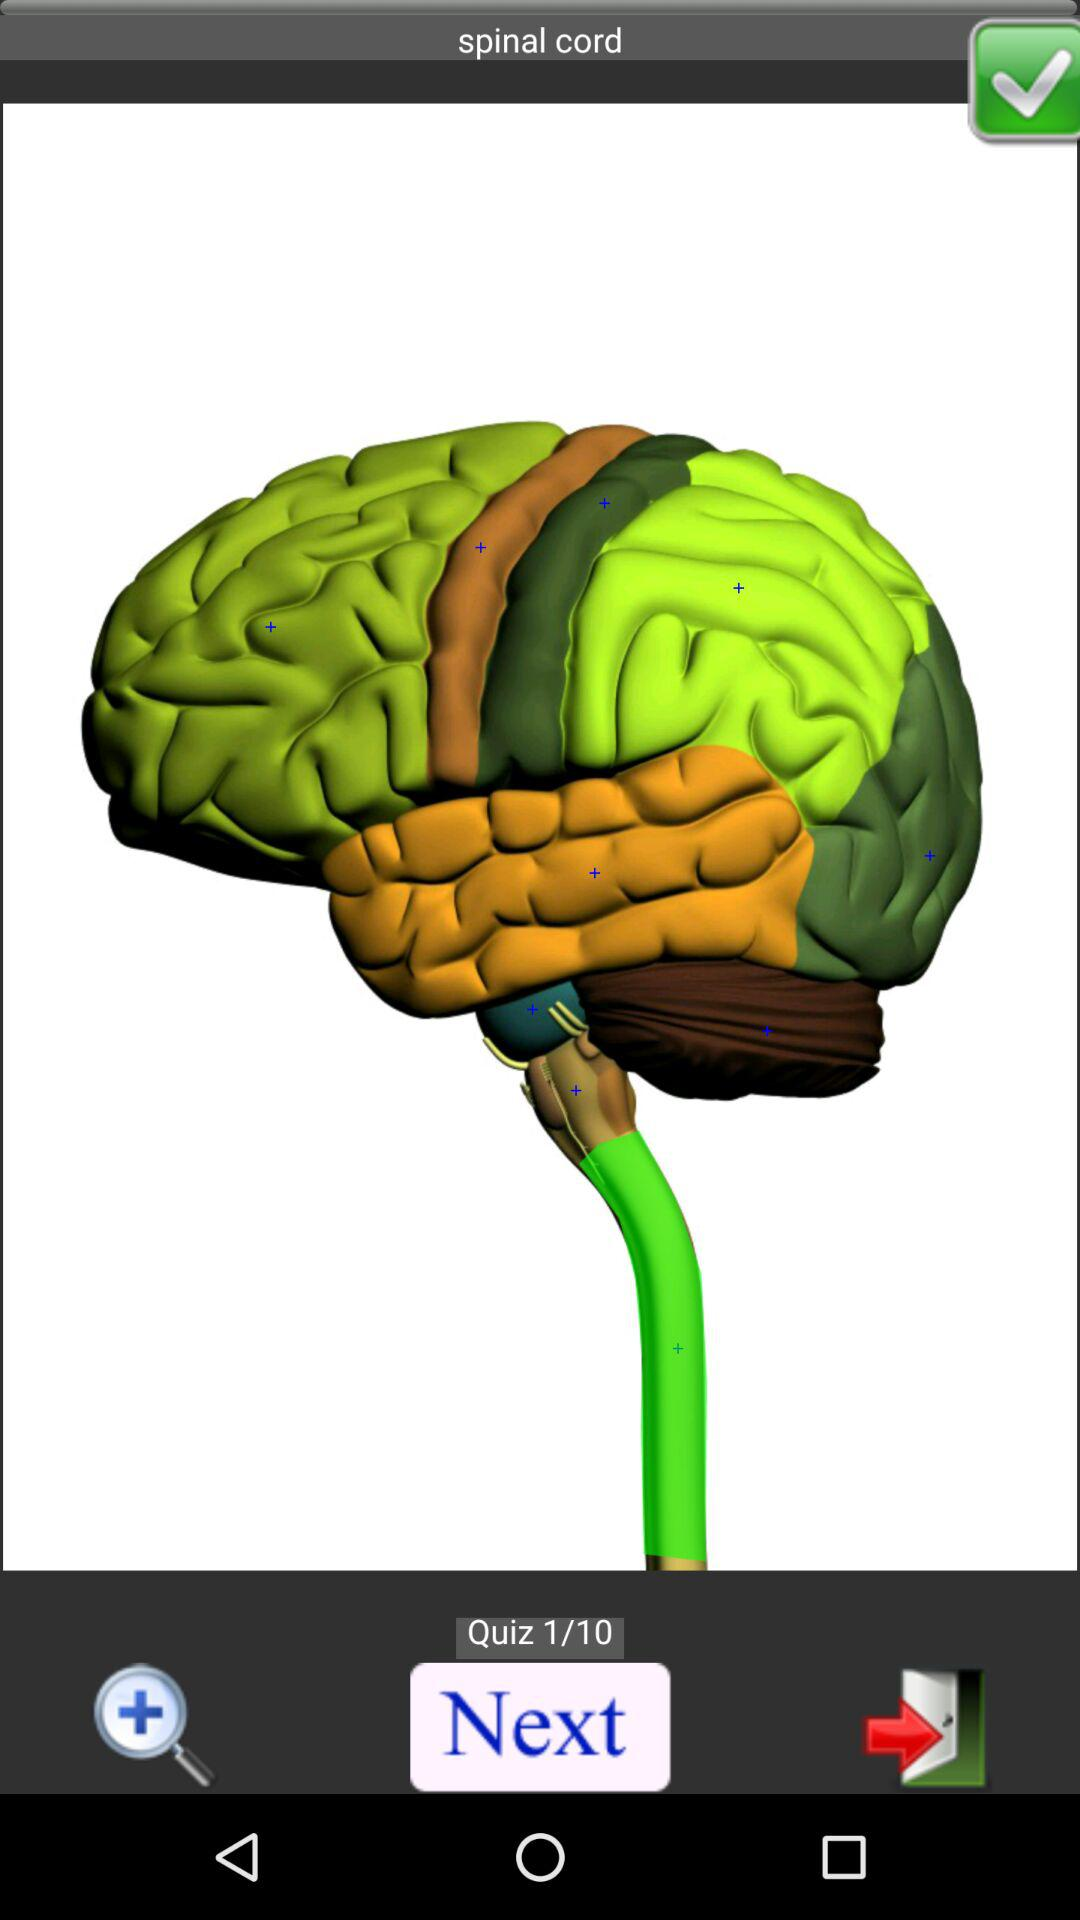At which quiz am I? You are at the first quiz. 